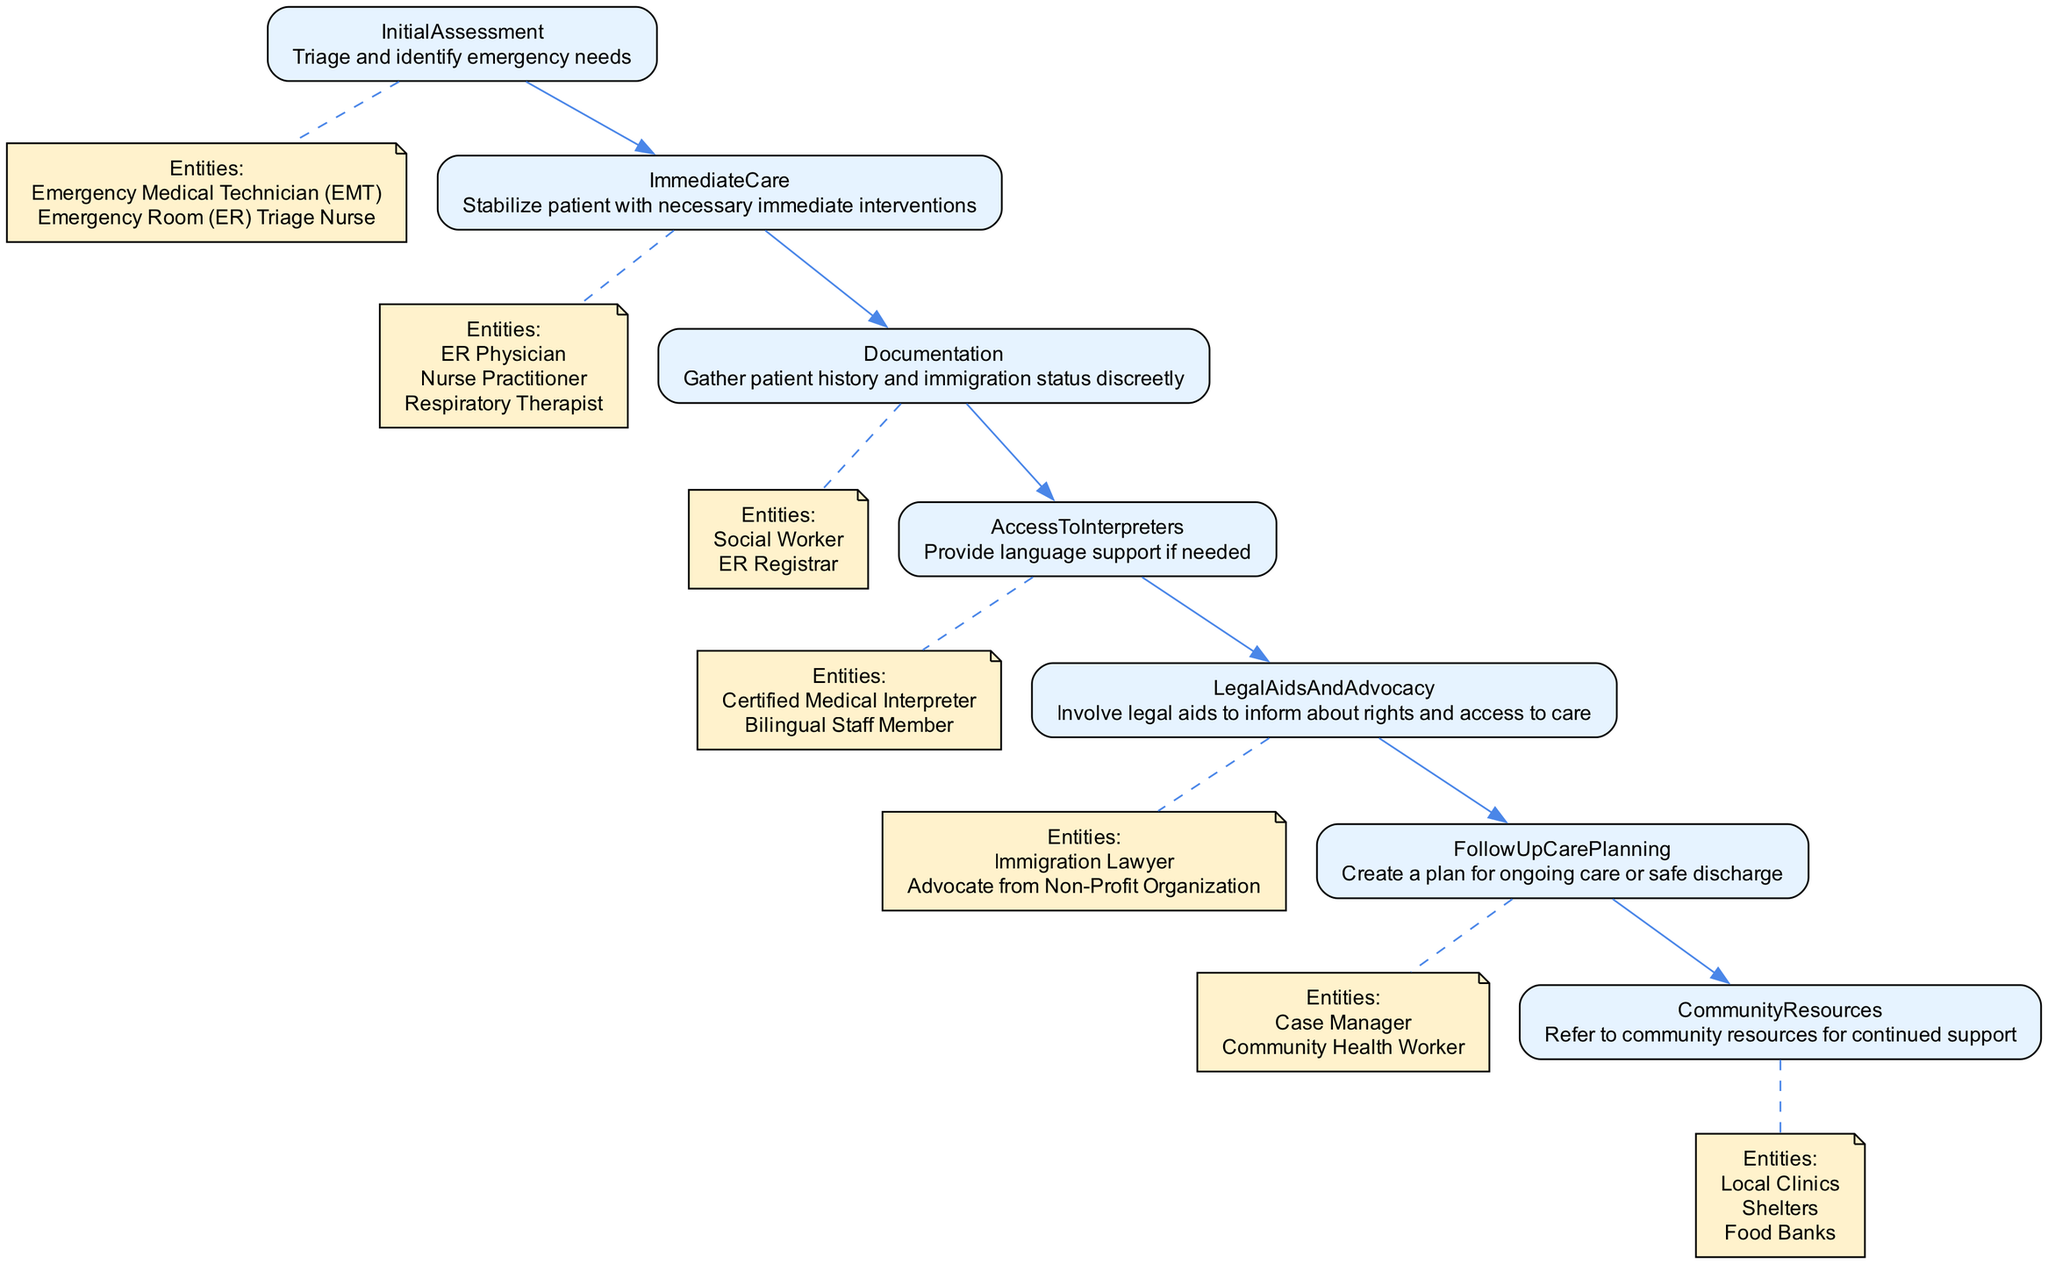What is the first step in the pathway? The first step in the pathway is "InitialAssessment" which is indicated as the starting node before any other steps.
Answer: InitialAssessment How many entities are involved in ImmediateCare? The "ImmediateCare" step lists three entities involved: ER Physician, Nurse Practitioner, and Respiratory Therapist. Counting these gives a total of three.
Answer: 3 What is the relationship between Documentation and LegalAidsAndAdvocacy? "Documentation" is connected to "LegalAidsAndAdvocacy" through a direct edge in the pathway, indicating a flow from one step to the next.
Answer: Direct edge Which step involves language support? The step involving language support is "AccessToInterpreters," where it mentions providing language assistance if necessary.
Answer: AccessToInterpreters What is the last step in the pathway of care? The last step in the pathway is "CommunityResources," representing the final node in the clinical pathway.
Answer: CommunityResources List two entities involved in the InitialAssessment. The "InitialAssessment" step includes two entities: Emergency Medical Technician (EMT) and Emergency Room (ER) Triage Nurse, which can be identified in the diagram under that step.
Answer: Emergency Medical Technician (EMT), Emergency Room (ER) Triage Nurse How does FollowUpCarePlanning relate to CommunityResources? "FollowUpCarePlanning" leads to "CommunityResources," showing that there is a pathway from planning care to connecting with community support resources.
Answer: Pathway What is the purpose of LegalAidsAndAdvocacy in this pathway? The purpose of "LegalAidsAndAdvocacy" is to involve legal aids that inform individuals about their rights and access to care, clearly stated in its description.
Answer: Inform about rights and access to care 